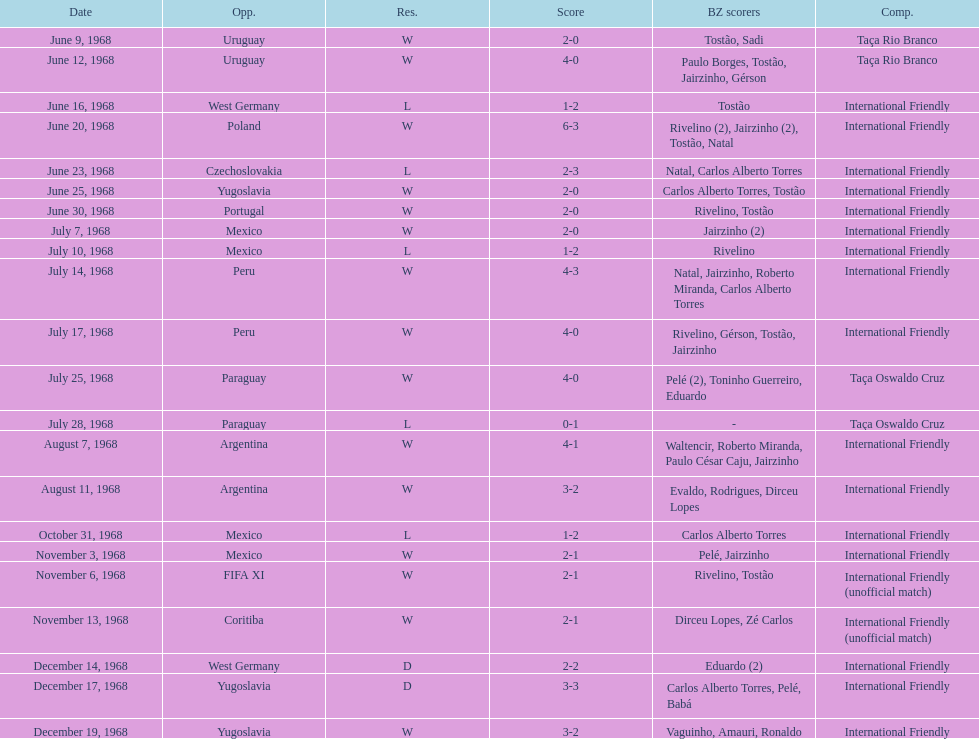Total number of wins 15. Would you mind parsing the complete table? {'header': ['Date', 'Opp.', 'Res.', 'Score', 'BZ scorers', 'Comp.'], 'rows': [['June 9, 1968', 'Uruguay', 'W', '2-0', 'Tostão, Sadi', 'Taça Rio Branco'], ['June 12, 1968', 'Uruguay', 'W', '4-0', 'Paulo Borges, Tostão, Jairzinho, Gérson', 'Taça Rio Branco'], ['June 16, 1968', 'West Germany', 'L', '1-2', 'Tostão', 'International Friendly'], ['June 20, 1968', 'Poland', 'W', '6-3', 'Rivelino (2), Jairzinho (2), Tostão, Natal', 'International Friendly'], ['June 23, 1968', 'Czechoslovakia', 'L', '2-3', 'Natal, Carlos Alberto Torres', 'International Friendly'], ['June 25, 1968', 'Yugoslavia', 'W', '2-0', 'Carlos Alberto Torres, Tostão', 'International Friendly'], ['June 30, 1968', 'Portugal', 'W', '2-0', 'Rivelino, Tostão', 'International Friendly'], ['July 7, 1968', 'Mexico', 'W', '2-0', 'Jairzinho (2)', 'International Friendly'], ['July 10, 1968', 'Mexico', 'L', '1-2', 'Rivelino', 'International Friendly'], ['July 14, 1968', 'Peru', 'W', '4-3', 'Natal, Jairzinho, Roberto Miranda, Carlos Alberto Torres', 'International Friendly'], ['July 17, 1968', 'Peru', 'W', '4-0', 'Rivelino, Gérson, Tostão, Jairzinho', 'International Friendly'], ['July 25, 1968', 'Paraguay', 'W', '4-0', 'Pelé (2), Toninho Guerreiro, Eduardo', 'Taça Oswaldo Cruz'], ['July 28, 1968', 'Paraguay', 'L', '0-1', '-', 'Taça Oswaldo Cruz'], ['August 7, 1968', 'Argentina', 'W', '4-1', 'Waltencir, Roberto Miranda, Paulo César Caju, Jairzinho', 'International Friendly'], ['August 11, 1968', 'Argentina', 'W', '3-2', 'Evaldo, Rodrigues, Dirceu Lopes', 'International Friendly'], ['October 31, 1968', 'Mexico', 'L', '1-2', 'Carlos Alberto Torres', 'International Friendly'], ['November 3, 1968', 'Mexico', 'W', '2-1', 'Pelé, Jairzinho', 'International Friendly'], ['November 6, 1968', 'FIFA XI', 'W', '2-1', 'Rivelino, Tostão', 'International Friendly (unofficial match)'], ['November 13, 1968', 'Coritiba', 'W', '2-1', 'Dirceu Lopes, Zé Carlos', 'International Friendly (unofficial match)'], ['December 14, 1968', 'West Germany', 'D', '2-2', 'Eduardo (2)', 'International Friendly'], ['December 17, 1968', 'Yugoslavia', 'D', '3-3', 'Carlos Alberto Torres, Pelé, Babá', 'International Friendly'], ['December 19, 1968', 'Yugoslavia', 'W', '3-2', 'Vaguinho, Amauri, Ronaldo', 'International Friendly']]} 